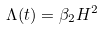<formula> <loc_0><loc_0><loc_500><loc_500>\Lambda ( t ) = \beta _ { 2 } H ^ { 2 }</formula> 